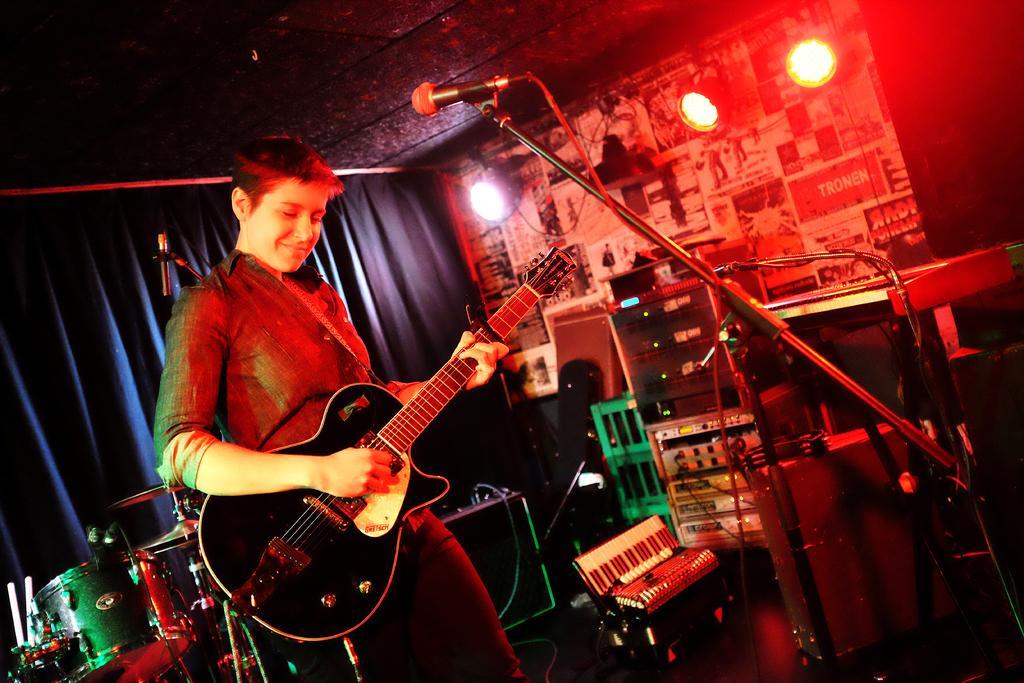In one or two sentences, can you explain what this image depicts? The person is playing guitar in front of a mic and there are some musical instruments behind him. 